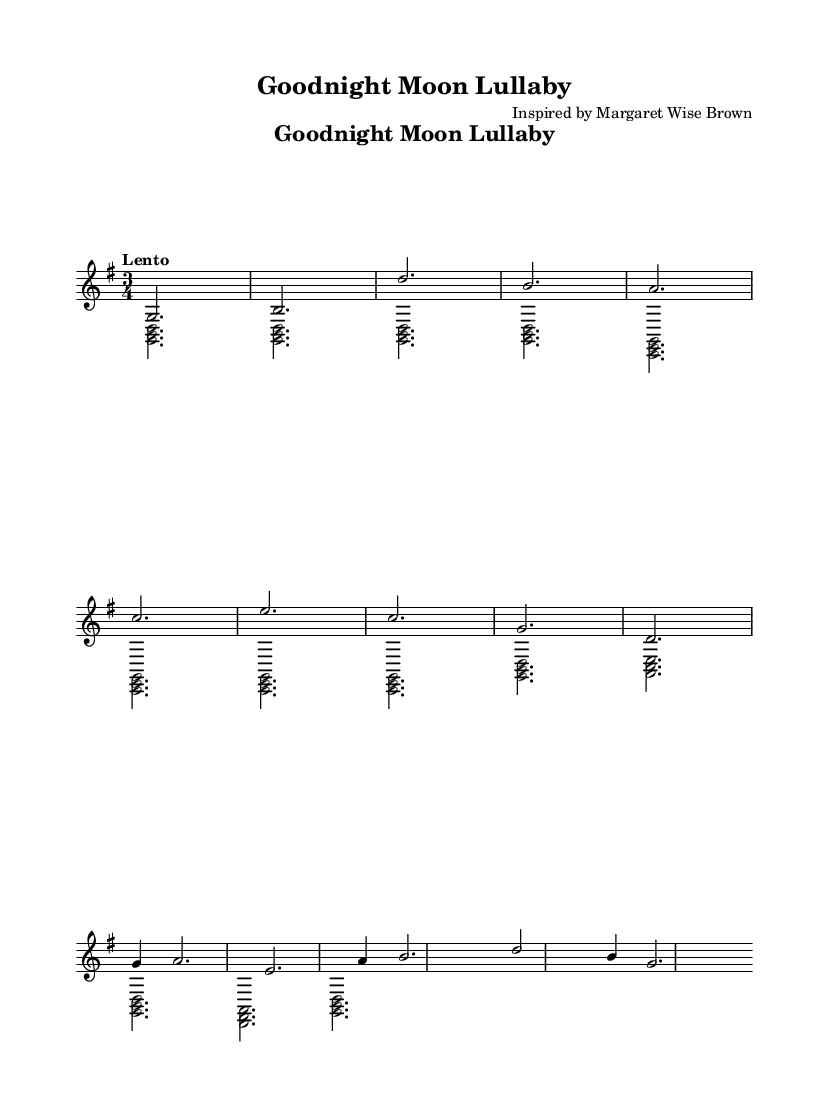What is the title of the piece? The title "Goodnight Moon Lullaby" is specified in the header section of the sheet music.
Answer: Goodnight Moon Lullaby Who is the composer inspired by? The composer is noted as being inspired by Margaret Wise Brown, which is indicated in the header at the top of the sheet music.
Answer: Margaret Wise Brown What is the key signature of this music? The key signature is G major, which has one sharp (F#), as derived from the key indicated in the global settings of the sheet music.
Answer: G major What is the time signature of the piece? The time signature is 3/4, which is explicitly stated in the global settings and defines the rhythmic structure of the music.
Answer: 3/4 What is the tempo marking for this lullaby? The tempo marking is "Lento", which suggests a slow pace for the piece, as mentioned in the global settings.
Answer: Lento What is the main melodic range of the piece? The melody starts on G and goes up to D, indicating the highest note, as seen in the melody lines; thus, the main melodic range is from G to D.
Answer: G to D How many measures are there in the melody? The melody consists of 12 measures, which is counted by sliding through the melody line and identifying the bar lines.
Answer: 12 